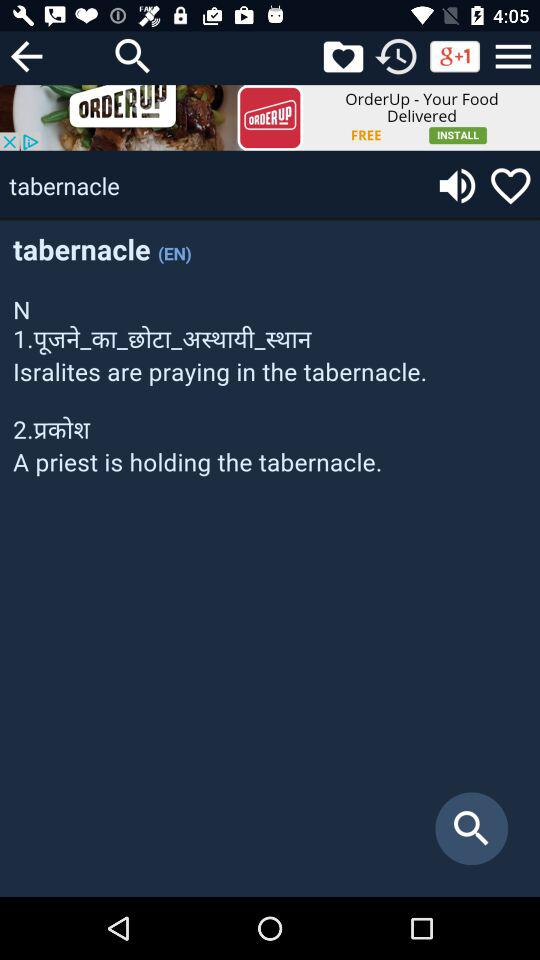What is the meaning of "tabernacle"? The "tabernacle" means "Isralites are praying in the tabernacle" and "A priest is holding the tabernacle". 